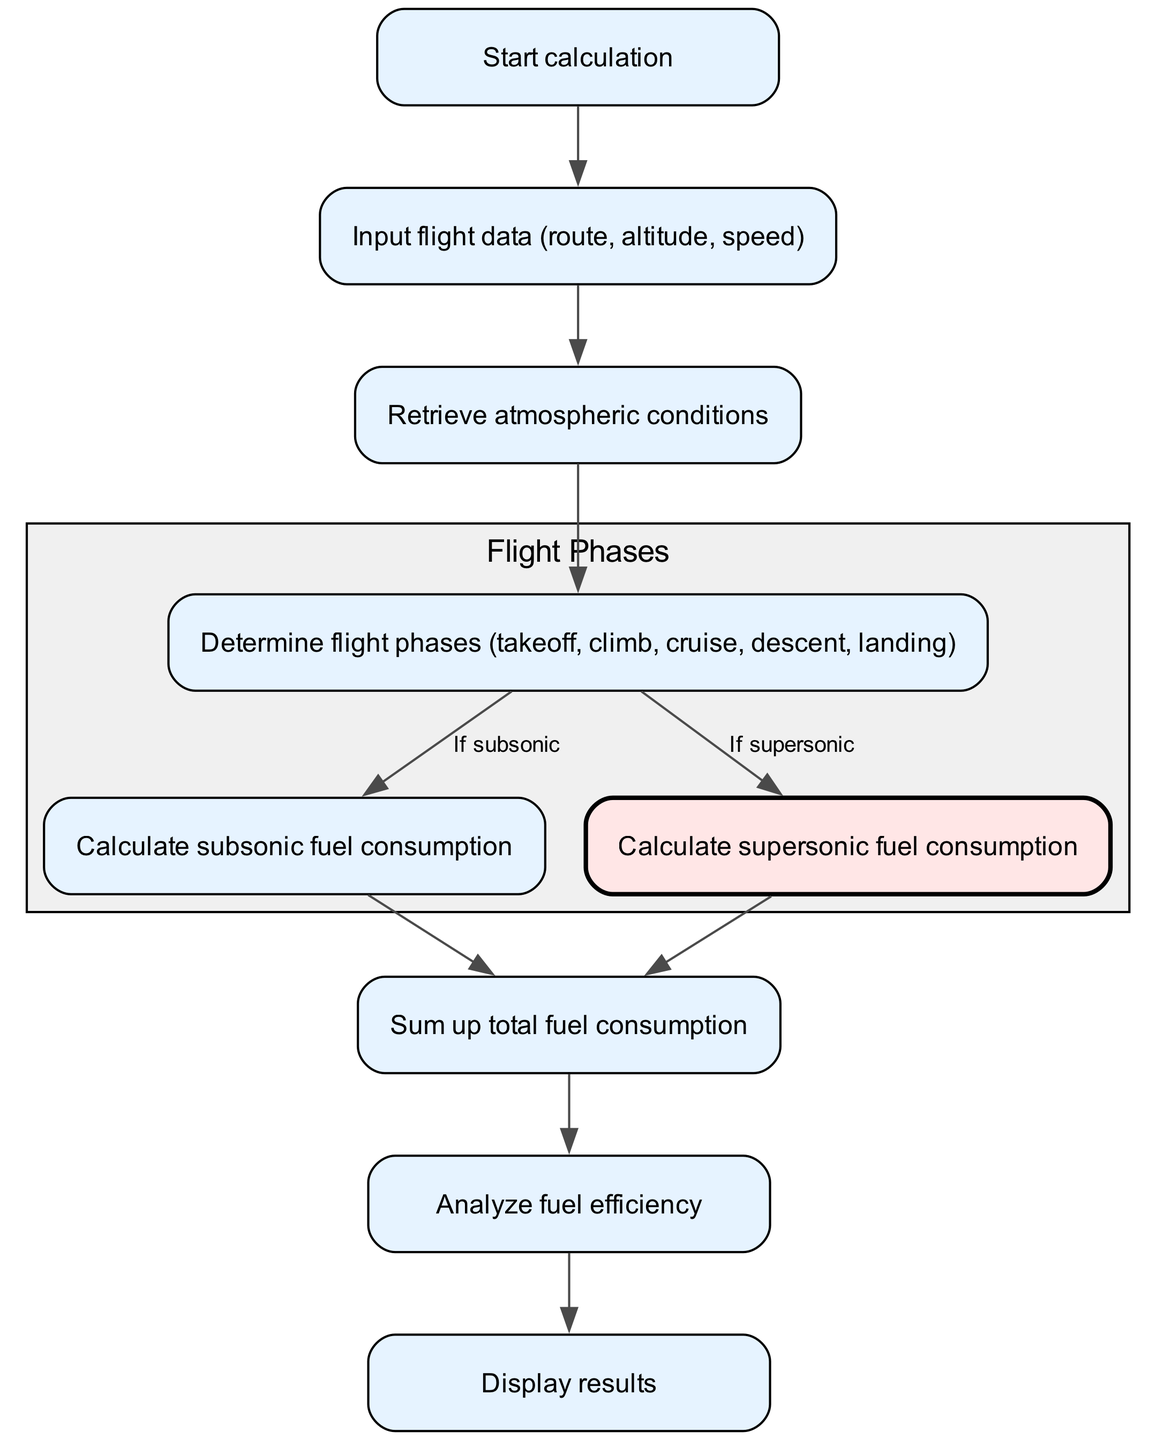What is the first step in the calculation process? The first step is to start the calculation as indicated by the node labeled "Start calculation." This is the entry point of the flowchart.
Answer: Start calculation How many total nodes are in the diagram? The diagram includes a total of 9 nodes as listed: Start calculation, Input flight data, Retrieve atmospheric conditions, Determine flight phases, Calculate subsonic fuel consumption, Calculate supersonic fuel consumption, Sum up total fuel consumption, Analyze fuel efficiency, Display results.
Answer: 9 What are the two types of fuel consumption calculated? The two types of fuel consumption calculated in the flowchart are "subsonic fuel consumption" and "supersonic fuel consumption," as identified in their respective nodes.
Answer: subsonic fuel consumption, supersonic fuel consumption What happens after determining flight phases? After determining the flight phases, the process either calculates subsonic fuel consumption or supersonic fuel consumption based on the type of flight, as shown by the outgoing edges from the "Determine flight phases" node.
Answer: Calculate fuel consumption What sequence follows the total fuel consumption? The sequence that follows the total fuel consumption is to analyze fuel efficiency, which is represented by the directed edge coming from the "Sum up total fuel consumption" node to the "Analyze fuel efficiency" node.
Answer: Analyze fuel efficiency Which atmospheric conditions are retrieved? The diagram does not specify the exact atmospheric conditions but shows that atmospheric conditions are retrieved after inputting flight data, indicating this step is a prerequisite for subsequent calculations.
Answer: Atmospheric conditions (not specified) Describe the cluster represented in the diagram. The cluster represents the flight phases, which includes the nodes for determining flight phases, calculating subsonic fuel consumption, and calculating supersonic fuel consumption, visually grouped to indicate their related functionality.
Answer: Flight phases What is the final output of the process? The final output of the process is the "Display results" node, which serves as the endpoint of the flowchart where calculated information is presented.
Answer: Display results What is the purpose of analyzing fuel efficiency? Analyzing fuel efficiency assesses the effectiveness of fuel consumption during different flight phases and is a necessary step before concluding the calculation process.
Answer: Effectiveness assessment 